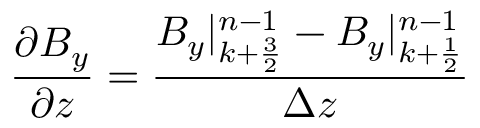Convert formula to latex. <formula><loc_0><loc_0><loc_500><loc_500>\frac { \partial B _ { y } } { \partial z } = \frac { B _ { y } | _ { k + \frac { 3 } { 2 } } ^ { n - 1 } - B _ { y } | _ { k + \frac { 1 } { 2 } } ^ { n - 1 } } { \Delta z }</formula> 